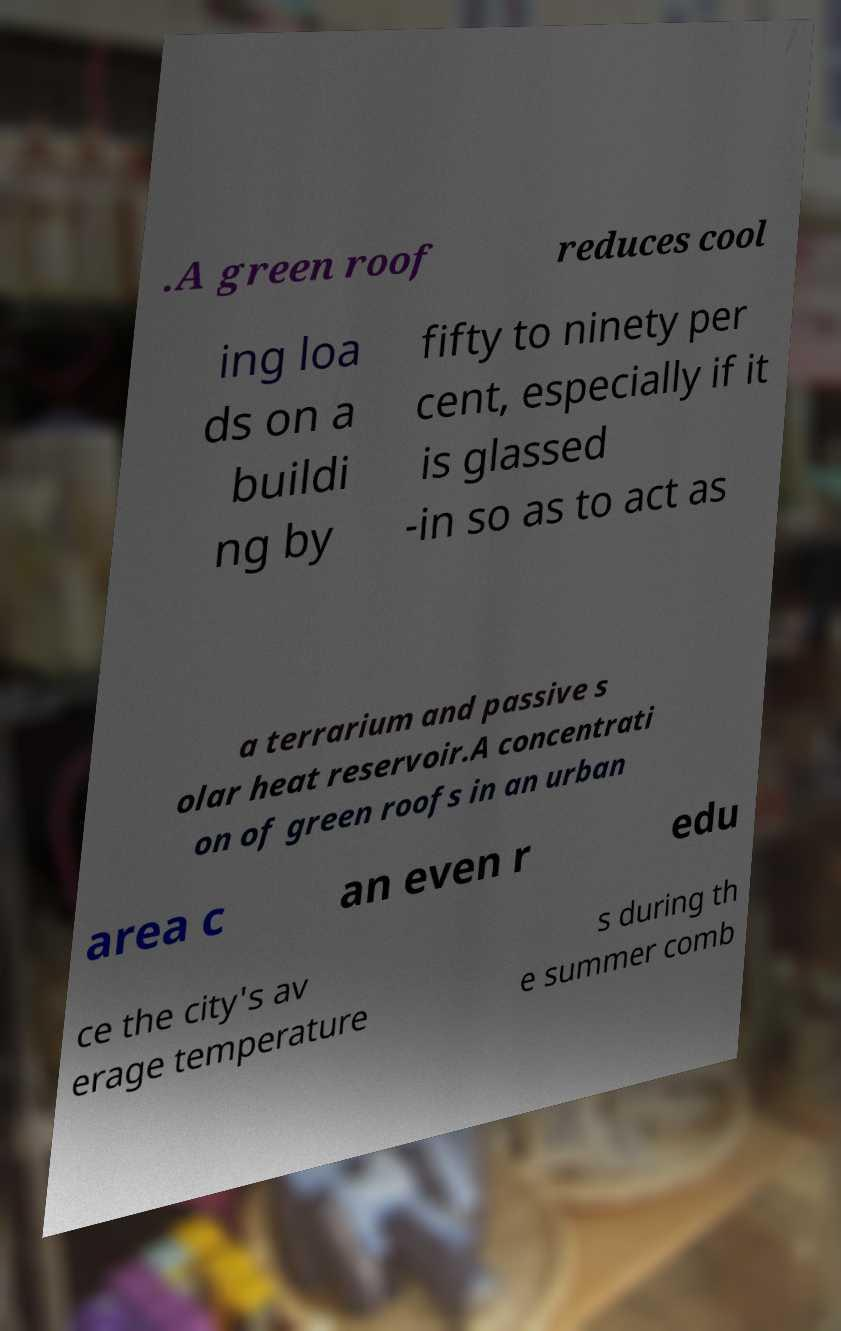Please read and relay the text visible in this image. What does it say? .A green roof reduces cool ing loa ds on a buildi ng by fifty to ninety per cent, especially if it is glassed -in so as to act as a terrarium and passive s olar heat reservoir.A concentrati on of green roofs in an urban area c an even r edu ce the city's av erage temperature s during th e summer comb 